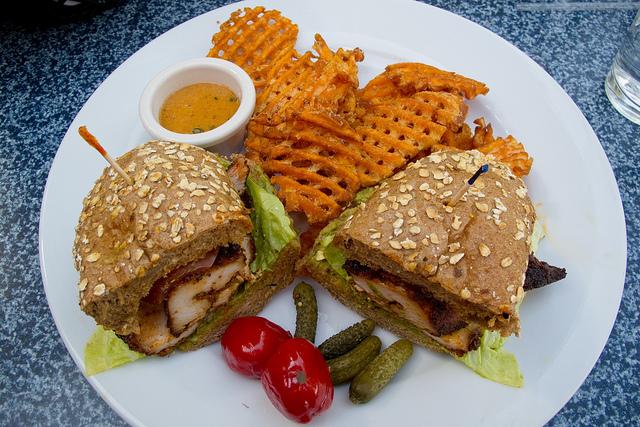What kind of sauce is that?
Concise answer only. Mustard. Is this a full meal?
Short answer required. Yes. What kind of fries are these?
Give a very brief answer. Waffle. What kind of food is on the plate?
Concise answer only. Sandwich. Is this plate of food healthy?
Keep it brief. Yes. What color is the table?
Quick response, please. Blue. What kind of bread is that?
Be succinct. Wheat. What is stuck in the meat?
Concise answer only. Toothpick. 